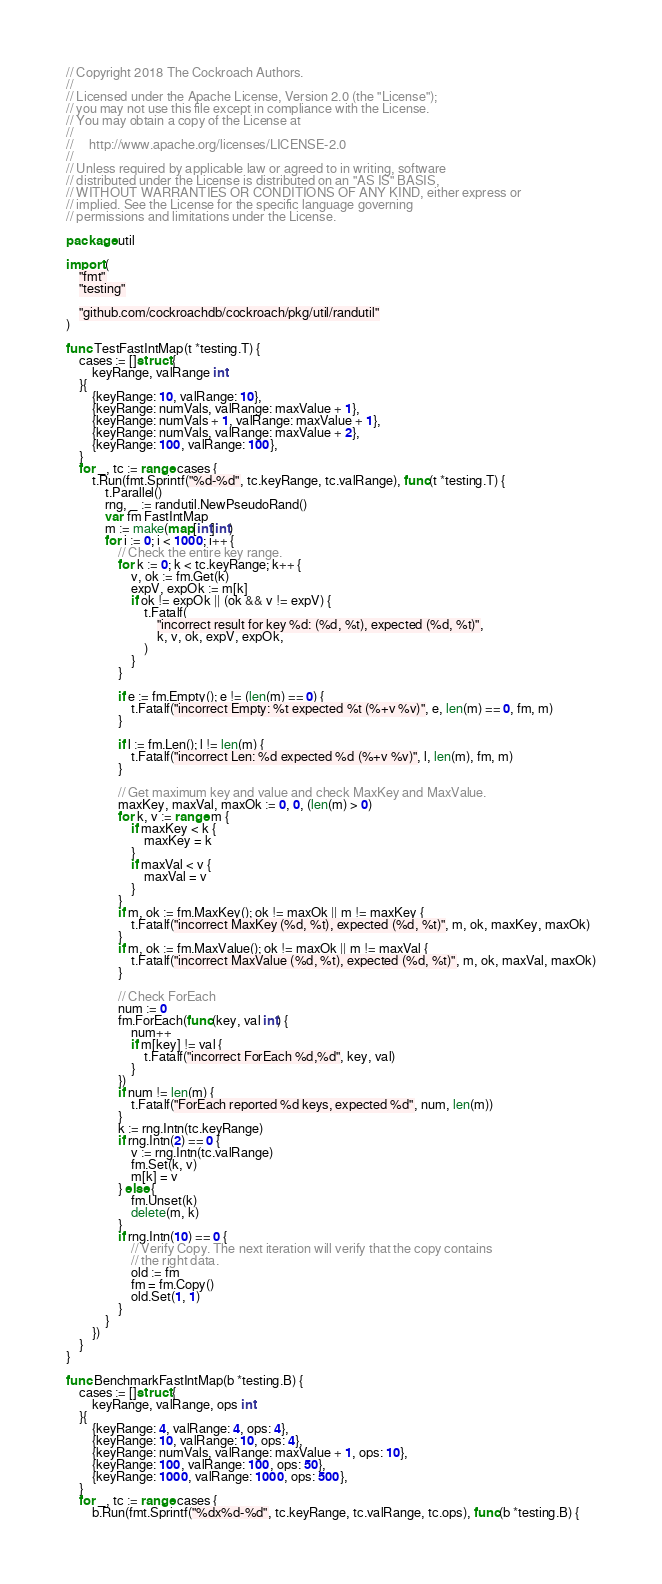Convert code to text. <code><loc_0><loc_0><loc_500><loc_500><_Go_>// Copyright 2018 The Cockroach Authors.
//
// Licensed under the Apache License, Version 2.0 (the "License");
// you may not use this file except in compliance with the License.
// You may obtain a copy of the License at
//
//     http://www.apache.org/licenses/LICENSE-2.0
//
// Unless required by applicable law or agreed to in writing, software
// distributed under the License is distributed on an "AS IS" BASIS,
// WITHOUT WARRANTIES OR CONDITIONS OF ANY KIND, either express or
// implied. See the License for the specific language governing
// permissions and limitations under the License.

package util

import (
	"fmt"
	"testing"

	"github.com/cockroachdb/cockroach/pkg/util/randutil"
)

func TestFastIntMap(t *testing.T) {
	cases := []struct {
		keyRange, valRange int
	}{
		{keyRange: 10, valRange: 10},
		{keyRange: numVals, valRange: maxValue + 1},
		{keyRange: numVals + 1, valRange: maxValue + 1},
		{keyRange: numVals, valRange: maxValue + 2},
		{keyRange: 100, valRange: 100},
	}
	for _, tc := range cases {
		t.Run(fmt.Sprintf("%d-%d", tc.keyRange, tc.valRange), func(t *testing.T) {
			t.Parallel()
			rng, _ := randutil.NewPseudoRand()
			var fm FastIntMap
			m := make(map[int]int)
			for i := 0; i < 1000; i++ {
				// Check the entire key range.
				for k := 0; k < tc.keyRange; k++ {
					v, ok := fm.Get(k)
					expV, expOk := m[k]
					if ok != expOk || (ok && v != expV) {
						t.Fatalf(
							"incorrect result for key %d: (%d, %t), expected (%d, %t)",
							k, v, ok, expV, expOk,
						)
					}
				}

				if e := fm.Empty(); e != (len(m) == 0) {
					t.Fatalf("incorrect Empty: %t expected %t (%+v %v)", e, len(m) == 0, fm, m)
				}

				if l := fm.Len(); l != len(m) {
					t.Fatalf("incorrect Len: %d expected %d (%+v %v)", l, len(m), fm, m)
				}

				// Get maximum key and value and check MaxKey and MaxValue.
				maxKey, maxVal, maxOk := 0, 0, (len(m) > 0)
				for k, v := range m {
					if maxKey < k {
						maxKey = k
					}
					if maxVal < v {
						maxVal = v
					}
				}
				if m, ok := fm.MaxKey(); ok != maxOk || m != maxKey {
					t.Fatalf("incorrect MaxKey (%d, %t), expected (%d, %t)", m, ok, maxKey, maxOk)
				}
				if m, ok := fm.MaxValue(); ok != maxOk || m != maxVal {
					t.Fatalf("incorrect MaxValue (%d, %t), expected (%d, %t)", m, ok, maxVal, maxOk)
				}

				// Check ForEach
				num := 0
				fm.ForEach(func(key, val int) {
					num++
					if m[key] != val {
						t.Fatalf("incorrect ForEach %d,%d", key, val)
					}
				})
				if num != len(m) {
					t.Fatalf("ForEach reported %d keys, expected %d", num, len(m))
				}
				k := rng.Intn(tc.keyRange)
				if rng.Intn(2) == 0 {
					v := rng.Intn(tc.valRange)
					fm.Set(k, v)
					m[k] = v
				} else {
					fm.Unset(k)
					delete(m, k)
				}
				if rng.Intn(10) == 0 {
					// Verify Copy. The next iteration will verify that the copy contains
					// the right data.
					old := fm
					fm = fm.Copy()
					old.Set(1, 1)
				}
			}
		})
	}
}

func BenchmarkFastIntMap(b *testing.B) {
	cases := []struct {
		keyRange, valRange, ops int
	}{
		{keyRange: 4, valRange: 4, ops: 4},
		{keyRange: 10, valRange: 10, ops: 4},
		{keyRange: numVals, valRange: maxValue + 1, ops: 10},
		{keyRange: 100, valRange: 100, ops: 50},
		{keyRange: 1000, valRange: 1000, ops: 500},
	}
	for _, tc := range cases {
		b.Run(fmt.Sprintf("%dx%d-%d", tc.keyRange, tc.valRange, tc.ops), func(b *testing.B) {</code> 